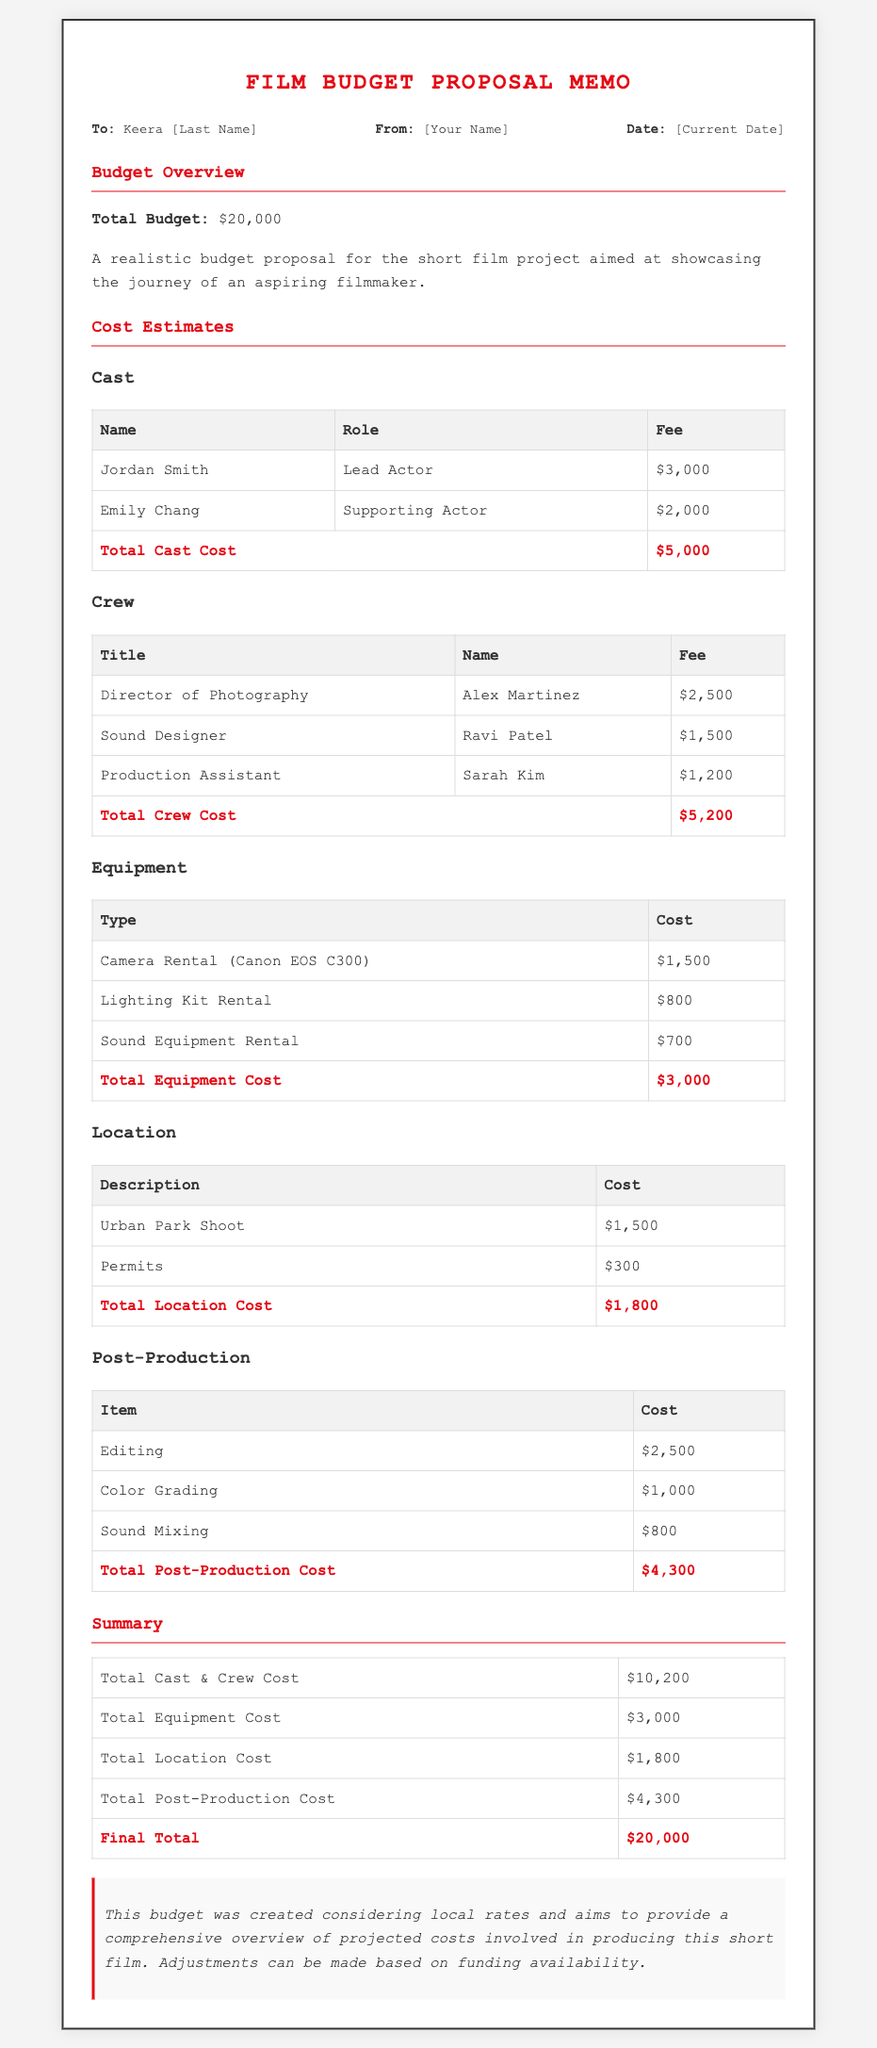What is the total budget? The total budget is stated in the document as $20,000.
Answer: $20,000 Who is the lead actor? The cast section lists Jordan Smith as the lead actor.
Answer: Jordan Smith What is the fee for the Director of Photography? The cost estimates show Alex Martinez's fee as $2,500 for that role.
Answer: $2,500 What is the total equipment cost? The table in the cost estimates section sums the equipment cost to $3,000.
Answer: $3,000 What is the cost of the Urban Park Shoot location? The location cost table indicates that the Urban Park Shoot costs $1,500.
Answer: $1,500 How much is allocated for post-production? The total post-production cost can be found to be $4,300 in the summary table.
Answer: $4,300 What percentage of the total budget is allocated for cast and crew costs? The total cast and crew cost is $10,200, which is 51% of the total budget, $20,000.
Answer: 51% What type of document is this? This document presents a film budget proposal memo specifically.
Answer: Film budget proposal memo Who is this memo addressed to? The memo is addressed to Keera as indicated in the header section.
Answer: Keera 